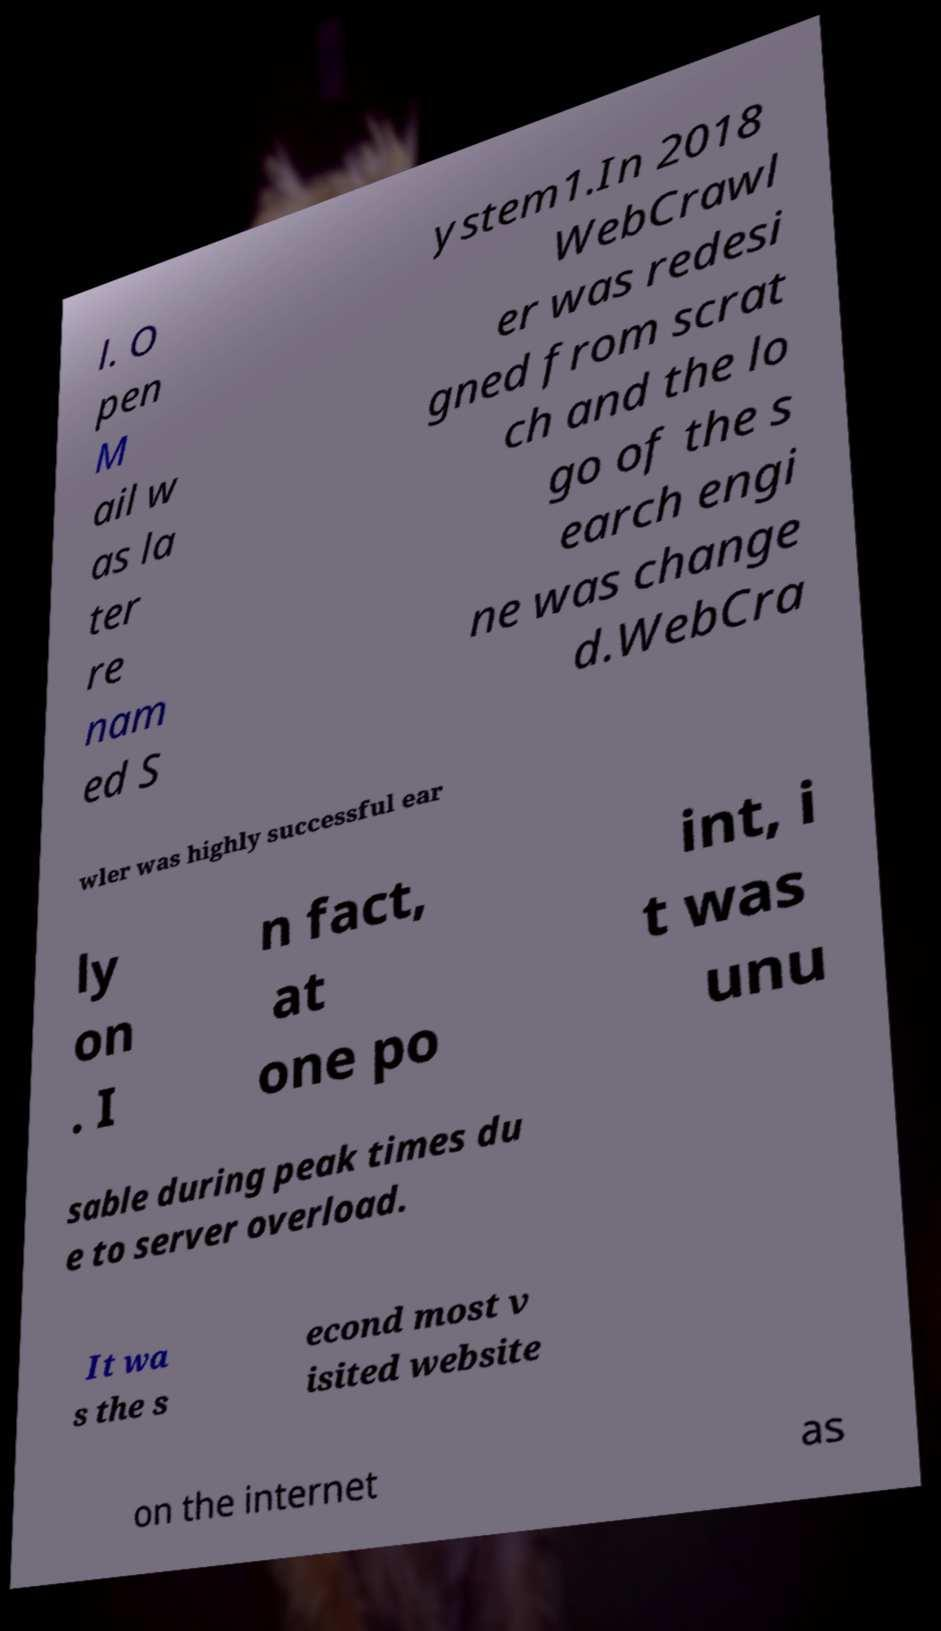Please read and relay the text visible in this image. What does it say? l. O pen M ail w as la ter re nam ed S ystem1.In 2018 WebCrawl er was redesi gned from scrat ch and the lo go of the s earch engi ne was change d.WebCra wler was highly successful ear ly on . I n fact, at one po int, i t was unu sable during peak times du e to server overload. It wa s the s econd most v isited website on the internet as 